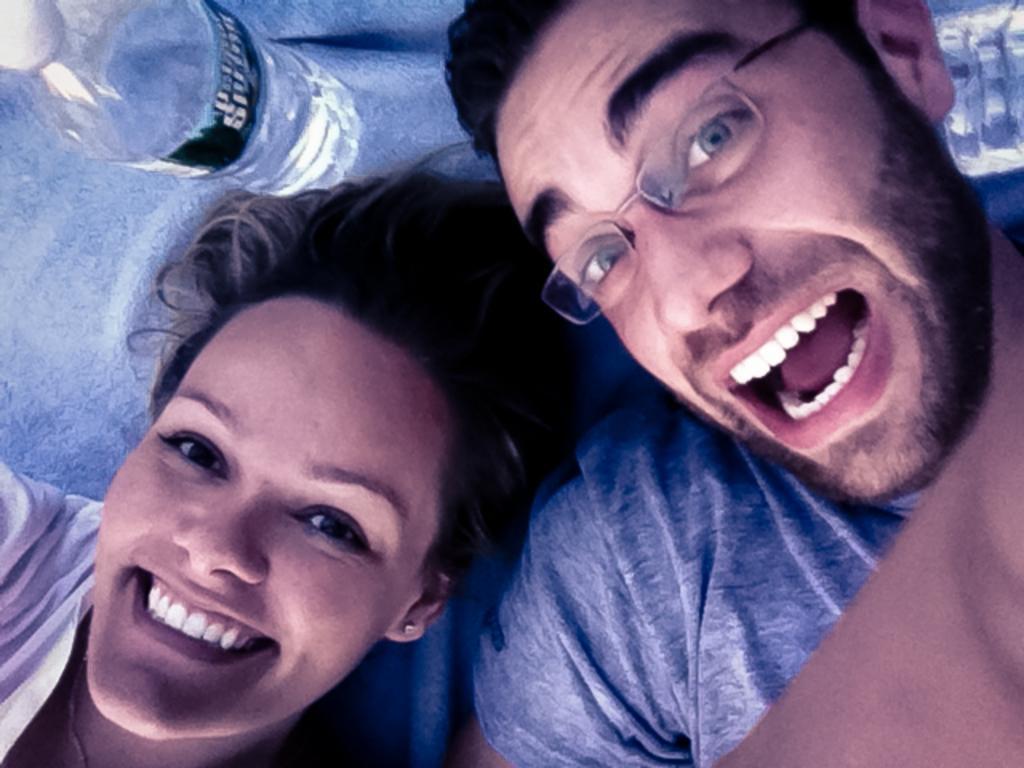Please provide a concise description of this image. In this image we can see a girl and a boy with a smile on their face and they are looking to the camera, besides their head there are water bottles. 